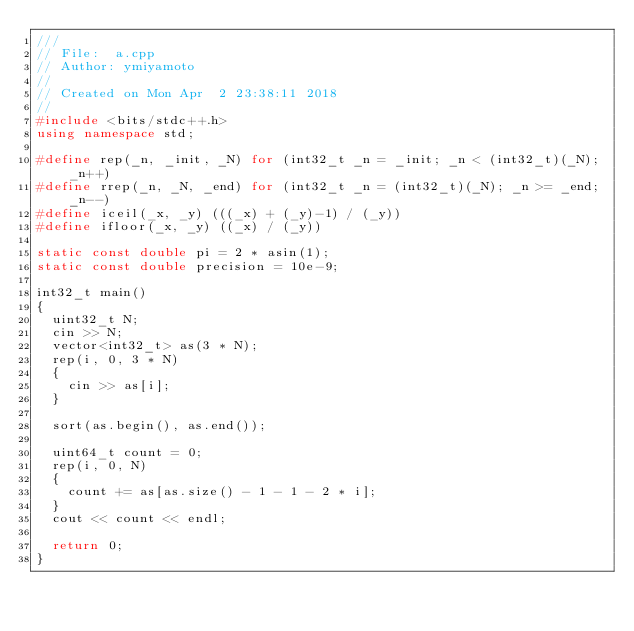Convert code to text. <code><loc_0><loc_0><loc_500><loc_500><_C++_>///
// File:  a.cpp
// Author: ymiyamoto
//
// Created on Mon Apr  2 23:38:11 2018
//
#include <bits/stdc++.h>
using namespace std;

#define rep(_n, _init, _N) for (int32_t _n = _init; _n < (int32_t)(_N); _n++)
#define rrep(_n, _N, _end) for (int32_t _n = (int32_t)(_N); _n >= _end; _n--)
#define iceil(_x, _y) (((_x) + (_y)-1) / (_y))
#define ifloor(_x, _y) ((_x) / (_y))

static const double pi = 2 * asin(1);
static const double precision = 10e-9;

int32_t main()
{
  uint32_t N;
  cin >> N;
  vector<int32_t> as(3 * N);
  rep(i, 0, 3 * N)
  {
    cin >> as[i];
  }

  sort(as.begin(), as.end());

  uint64_t count = 0;
  rep(i, 0, N)
  {
    count += as[as.size() - 1 - 1 - 2 * i];
  }
  cout << count << endl;

  return 0;
}
</code> 